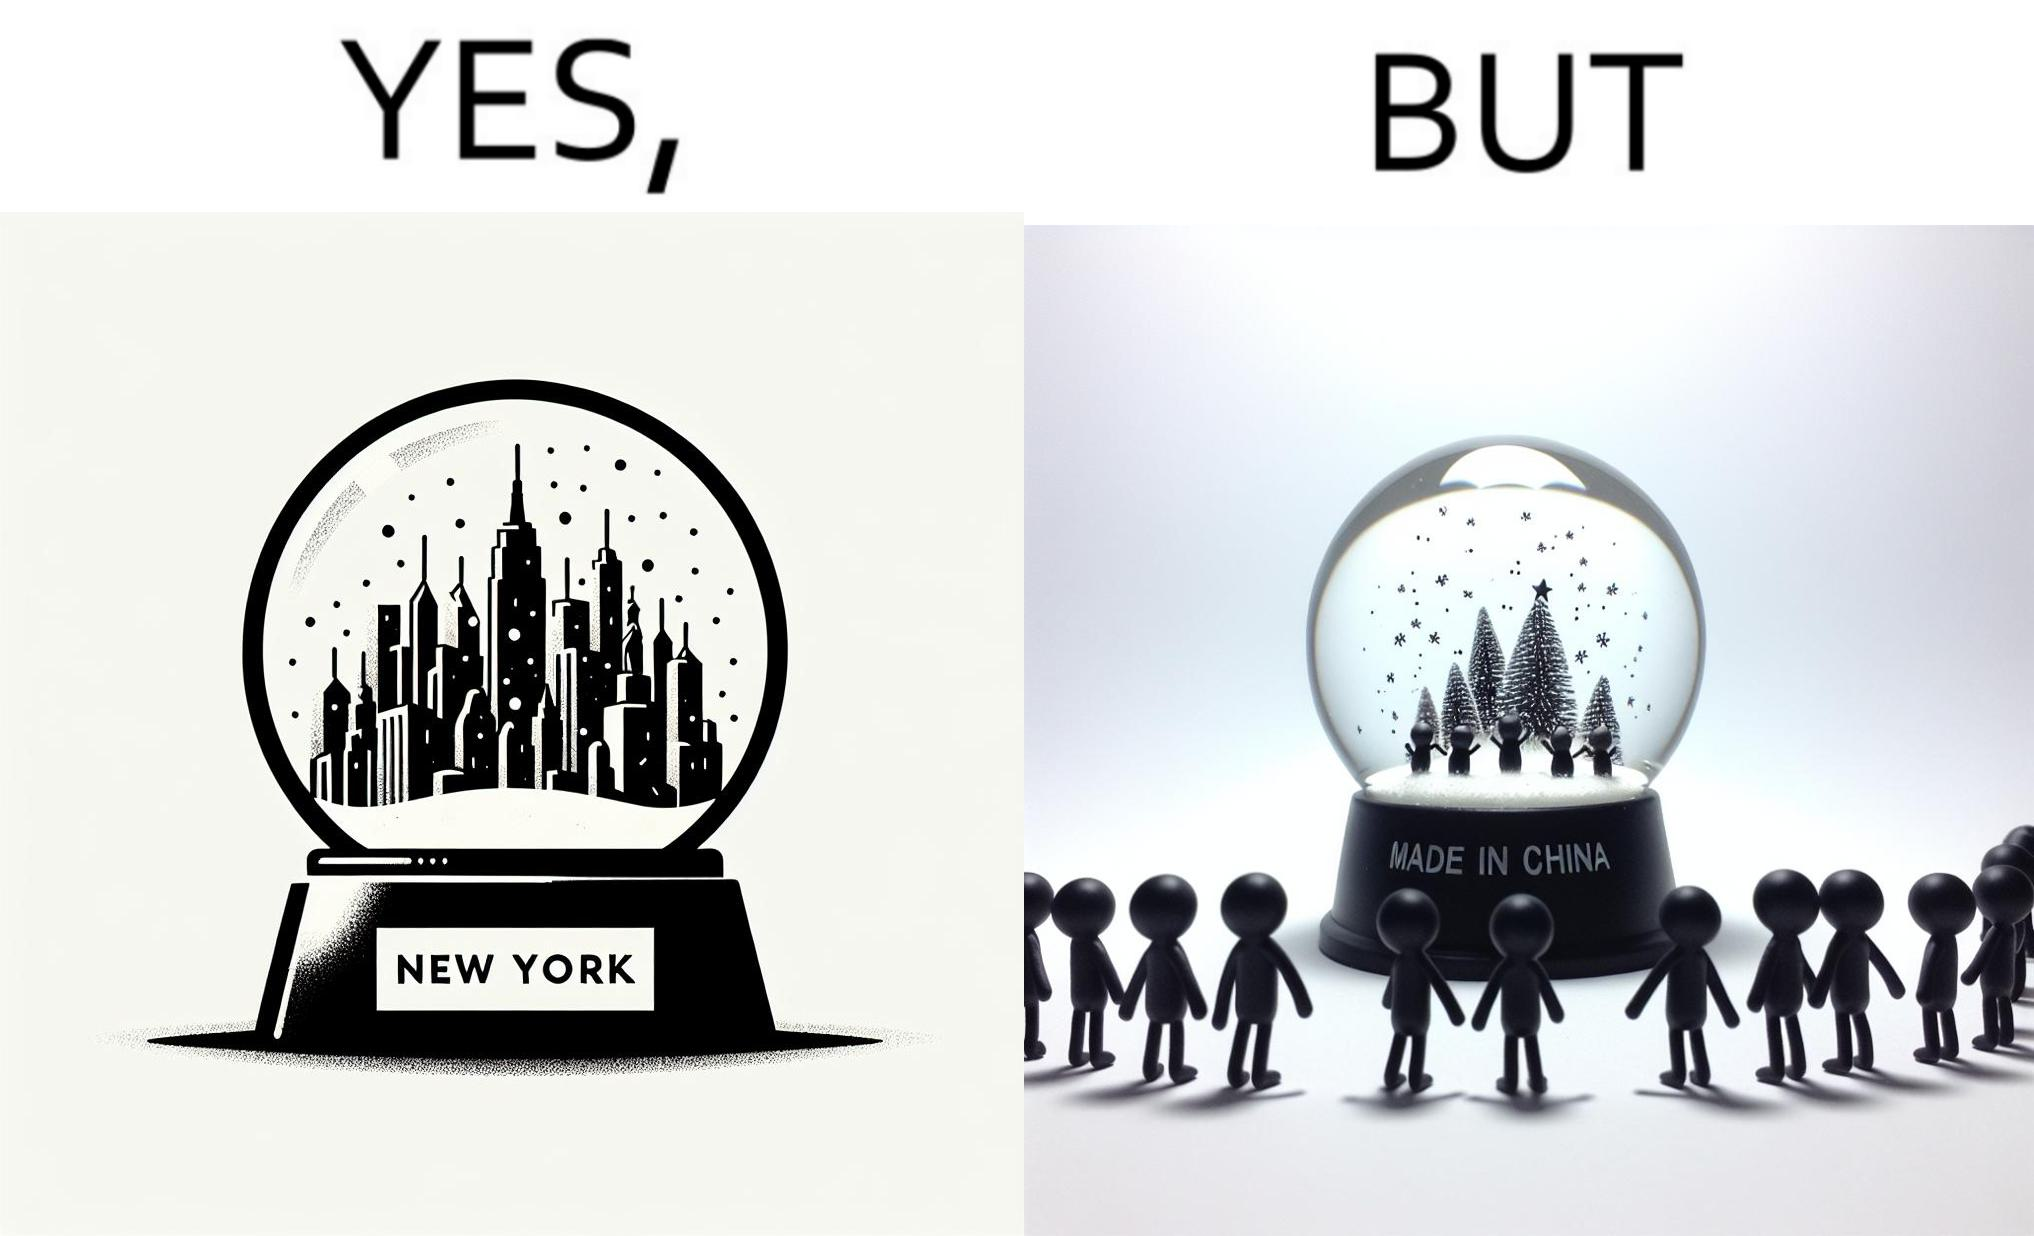Describe the satirical element in this image. The image is ironic because the snowglobe says 'New York' while it is made in China 